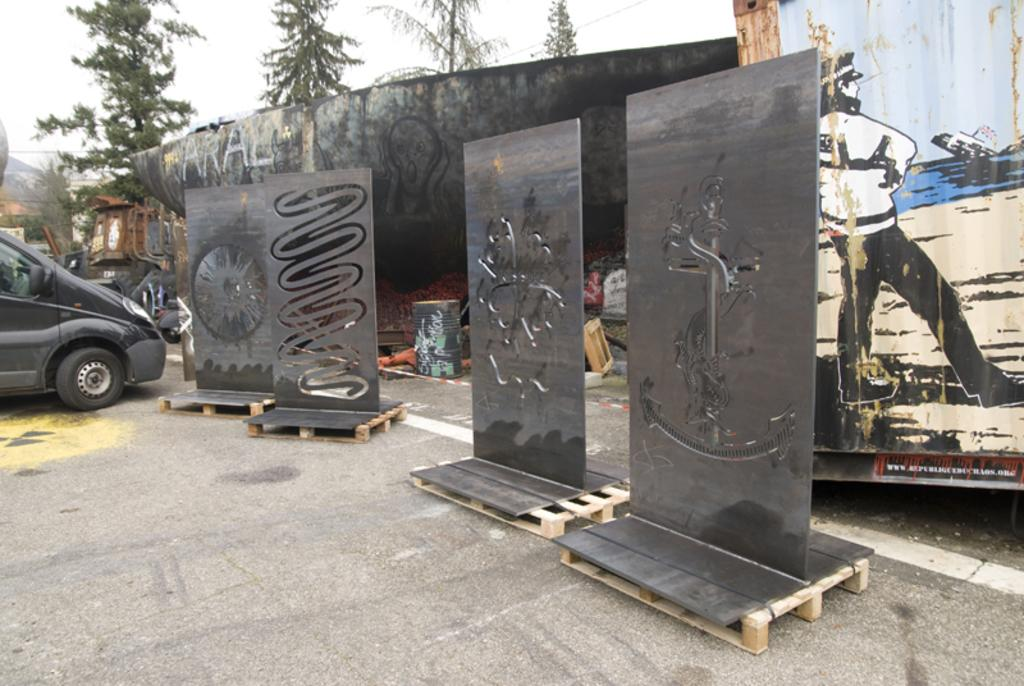What objects are placed on wooden stands in the image? There are boards placed on wooden stands in the image. What type of pathway can be seen in the image? There is a road visible in the image. What vehicle is present in the image? There is a car in the image. What type of signage is visible in the image? There is an advertisement in the image. What part of the natural environment is visible in the image? The sky is visible in the image. What type of infrastructure is present in the image? Electric cables and a transformer are visible in the image. What type of geographical feature is visible in the background of the image? There are hills in the background of the image. What type of vegetation is present in the image? Trees are present in the image. How many heads of cabbage are visible on the car in the image? There are no heads of cabbage visible on the car in the image. How many girls are playing with the boards on the wooden stands in the image? There are no girls present in the image; only the boards, wooden stands, and other mentioned objects are visible. 